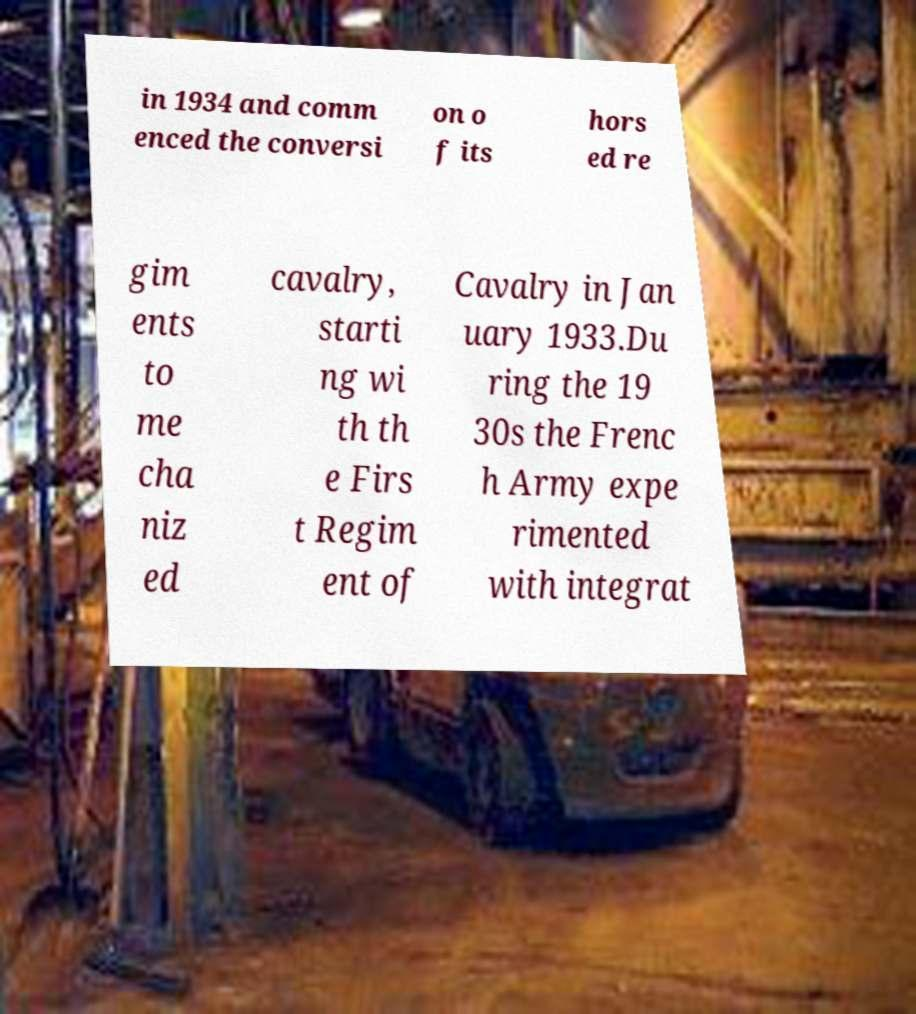Could you extract and type out the text from this image? in 1934 and comm enced the conversi on o f its hors ed re gim ents to me cha niz ed cavalry, starti ng wi th th e Firs t Regim ent of Cavalry in Jan uary 1933.Du ring the 19 30s the Frenc h Army expe rimented with integrat 